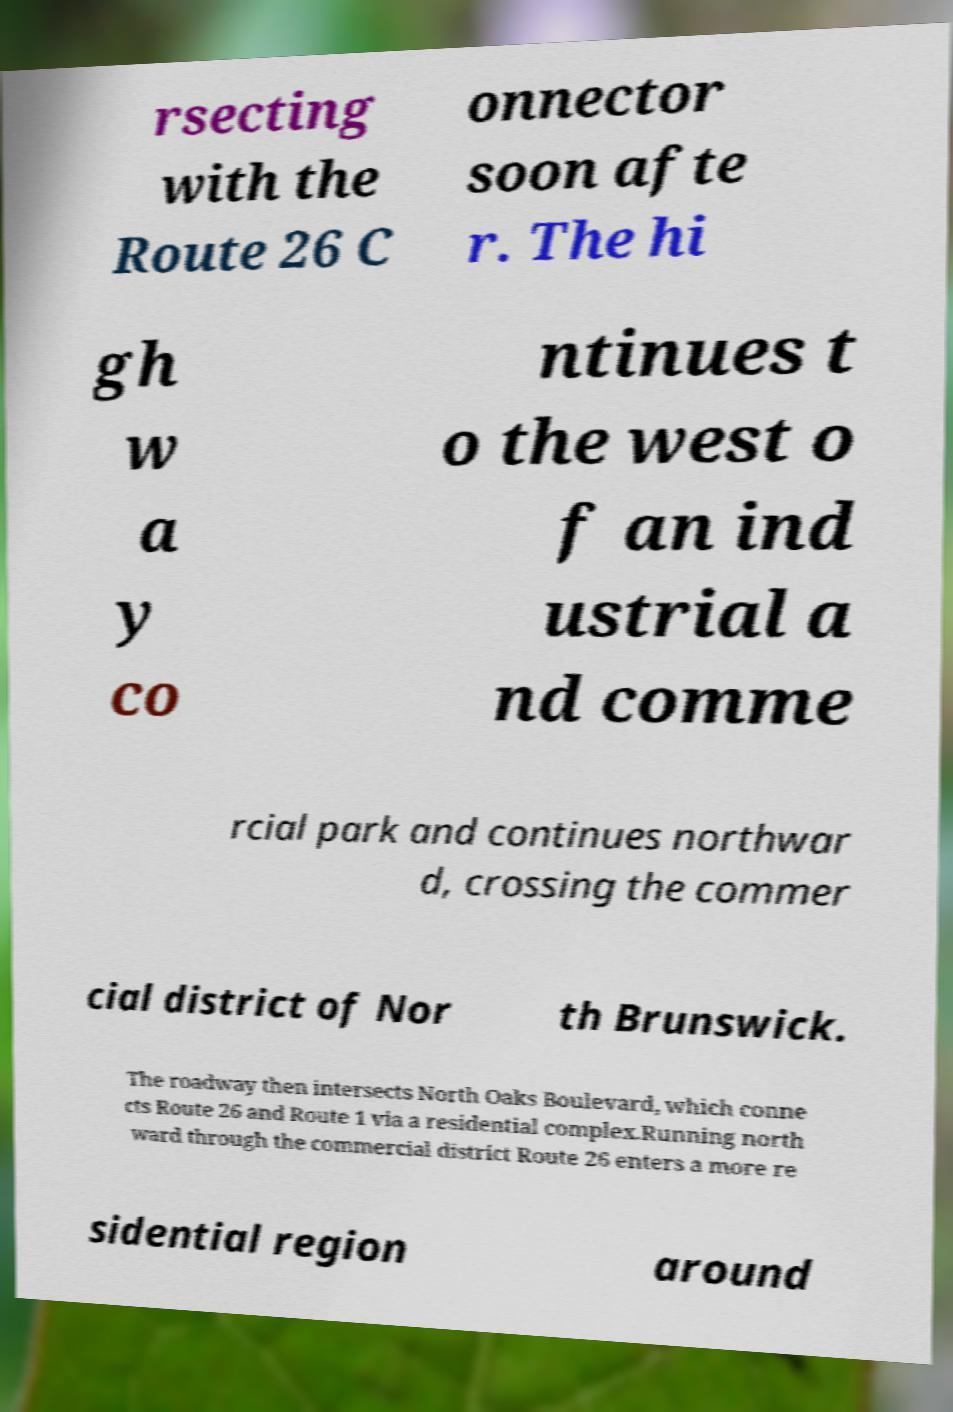Can you read and provide the text displayed in the image?This photo seems to have some interesting text. Can you extract and type it out for me? rsecting with the Route 26 C onnector soon afte r. The hi gh w a y co ntinues t o the west o f an ind ustrial a nd comme rcial park and continues northwar d, crossing the commer cial district of Nor th Brunswick. The roadway then intersects North Oaks Boulevard, which conne cts Route 26 and Route 1 via a residential complex.Running north ward through the commercial district Route 26 enters a more re sidential region around 